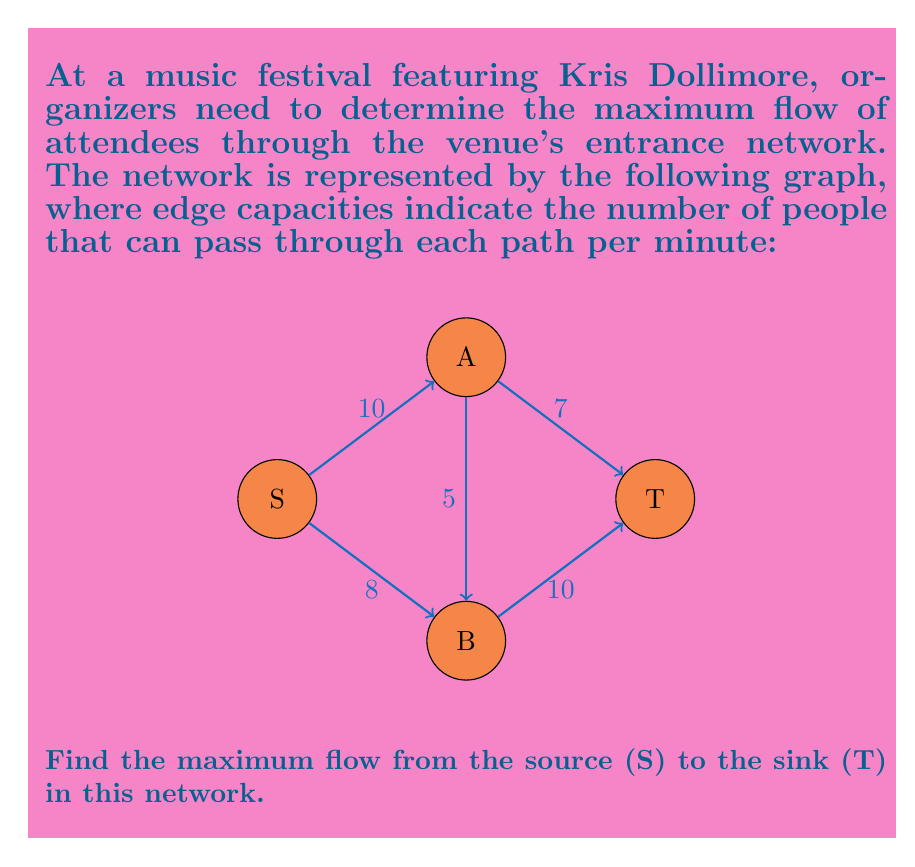Help me with this question. To find the maximum flow in this network, we'll use the Ford-Fulkerson algorithm:

1) Initialize flow on all edges to 0.

2) Find an augmenting path from S to T:
   Path 1: S → A → T (min capacity = 7)
   Augment flow by 7:
   $f(S,A) = 7$, $f(A,T) = 7$

3) Find another augmenting path:
   Path 2: S → B → T (min capacity = 8)
   Augment flow by 8:
   $f(S,B) = 8$, $f(B,T) = 8$

4) Find another augmenting path:
   Path 3: S → A → B → T (min capacity = 2)
   Augment flow by 2:
   $f(S,A) = 9$, $f(A,B) = 2$, $f(B,T) = 10$

5) No more augmenting paths exist.

6) Calculate total flow:
   Flow at T = $f(A,T) + f(B,T) = 7 + 10 = 17$

Therefore, the maximum flow in this network is 17 people per minute.

The residual graph after finding the maximum flow:

[asy]
import graph;

size(200);

real r = 0.5;
pair[] pos = {(-2,0), (0,1), (0,-1), (2,0)};
string[] lab = {"S", "A", "B", "T"};

for (int i = 0; i < 4; ++i) {
  draw(circle(pos[i], r));
  label(lab[i], pos[i]);
}

draw(pos[0]--pos[1], Arrow);
draw(pos[2]--pos[0], Arrow);
draw(pos[3]--pos[1], Arrow);
draw(pos[2]--pos[3], Arrow);
draw(pos[2]--pos[1], Arrow);

label("1", pos[0]--pos[1], N);
label("8", pos[2]--pos[0], S);
label("7", pos[3]--pos[1], N);
label("3", pos[2]--pos[1], W);
[/asy]
Answer: 17 people per minute 